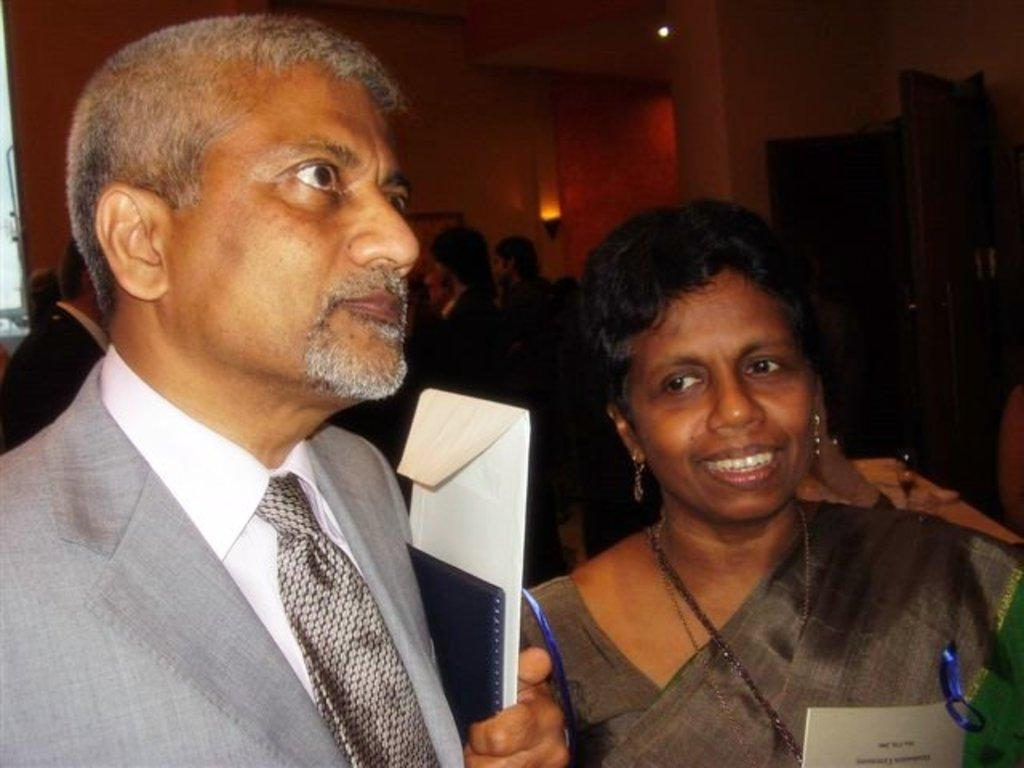Who are the people in the image? There is a woman and a man in the image. What is the woman doing with her mouth? The woman's mouth is open. Can you describe the background of the image? There are people, a wall, a light, and a beam in the background of the image. What is the man holding in the image? The man is holding a cover. What type of fork is being used to reward the station in the image? There is no fork, reward, or station present in the image. 